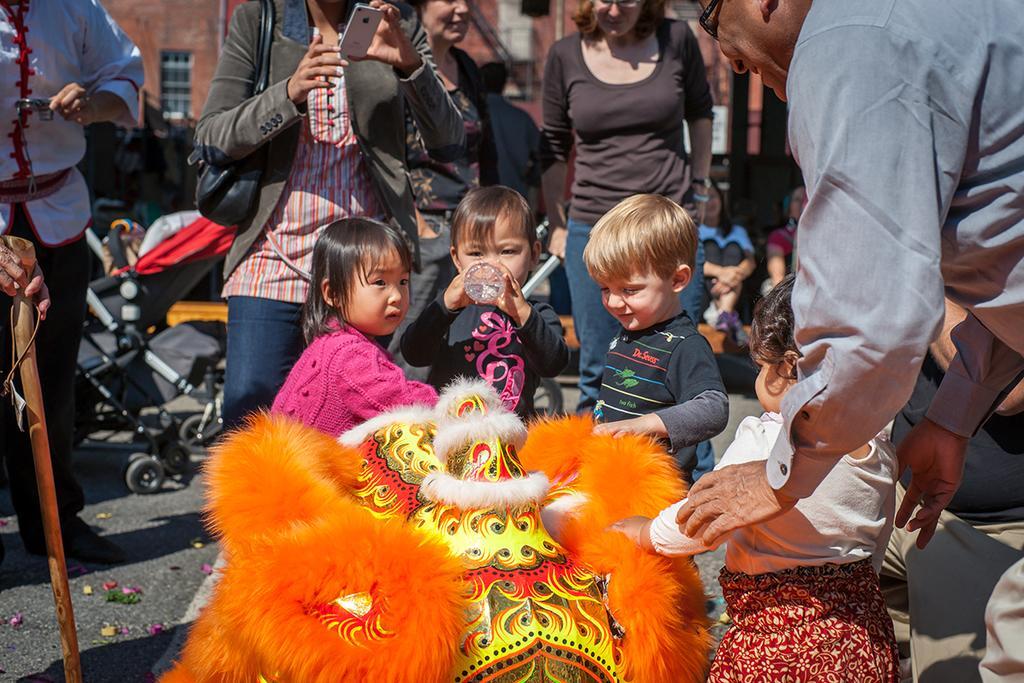Describe this image in one or two sentences. In this image on the right, there is a man, he wears a shirt, he is holding a baby. In the middle there are three children. On the left there is a woman, she wears a jacket, trouser, handbag, she is holding a mobile and there are some people. In the background there are some people, buildings, vehicles, road, window and wall. 